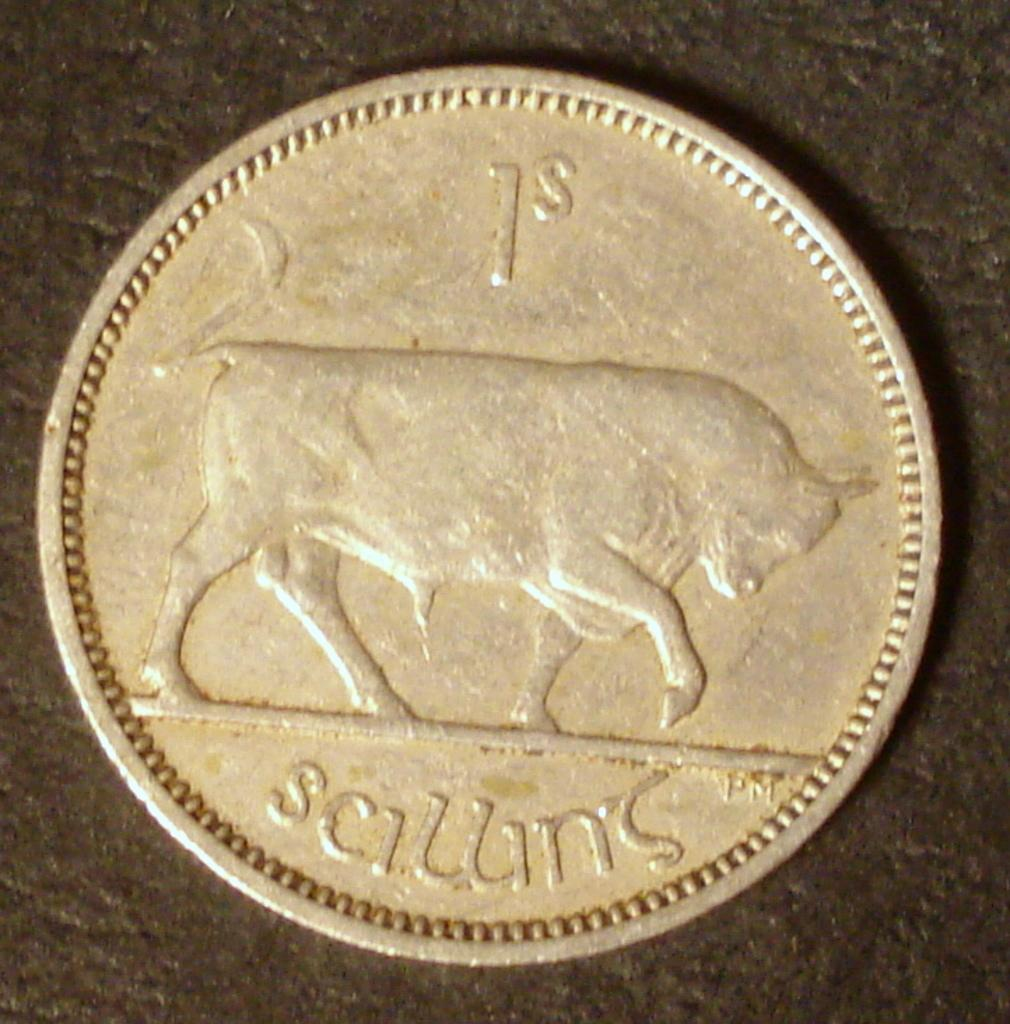Provide a one-sentence caption for the provided image. a close up of a coin for 1S and the image of a bull. 